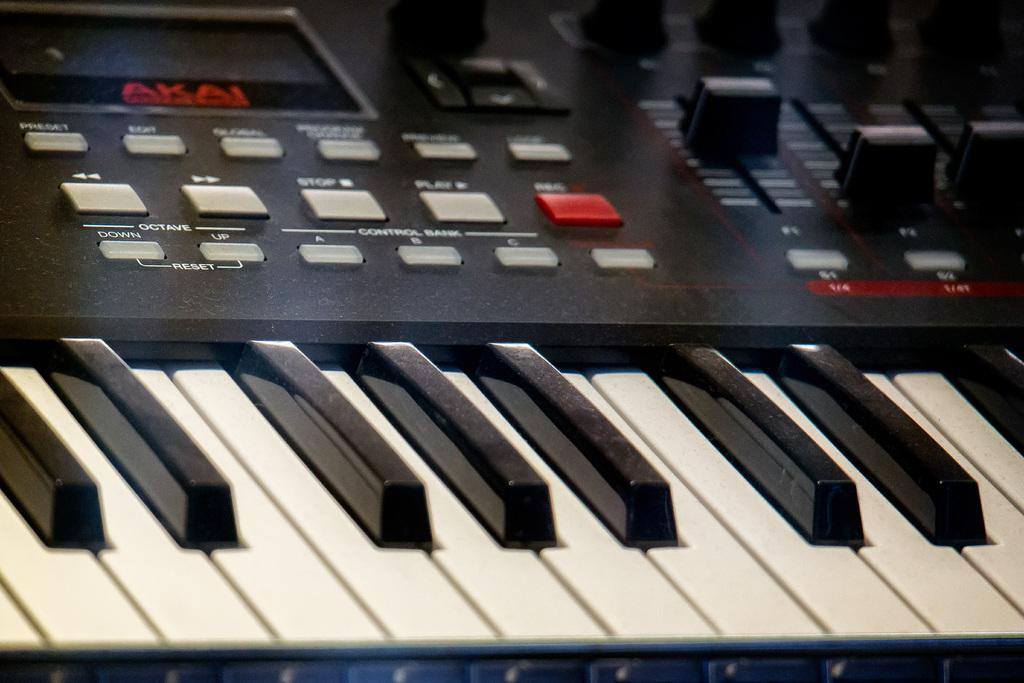Provide a one-sentence caption for the provided image. Black and white piano keys for an Akai keyboard. 